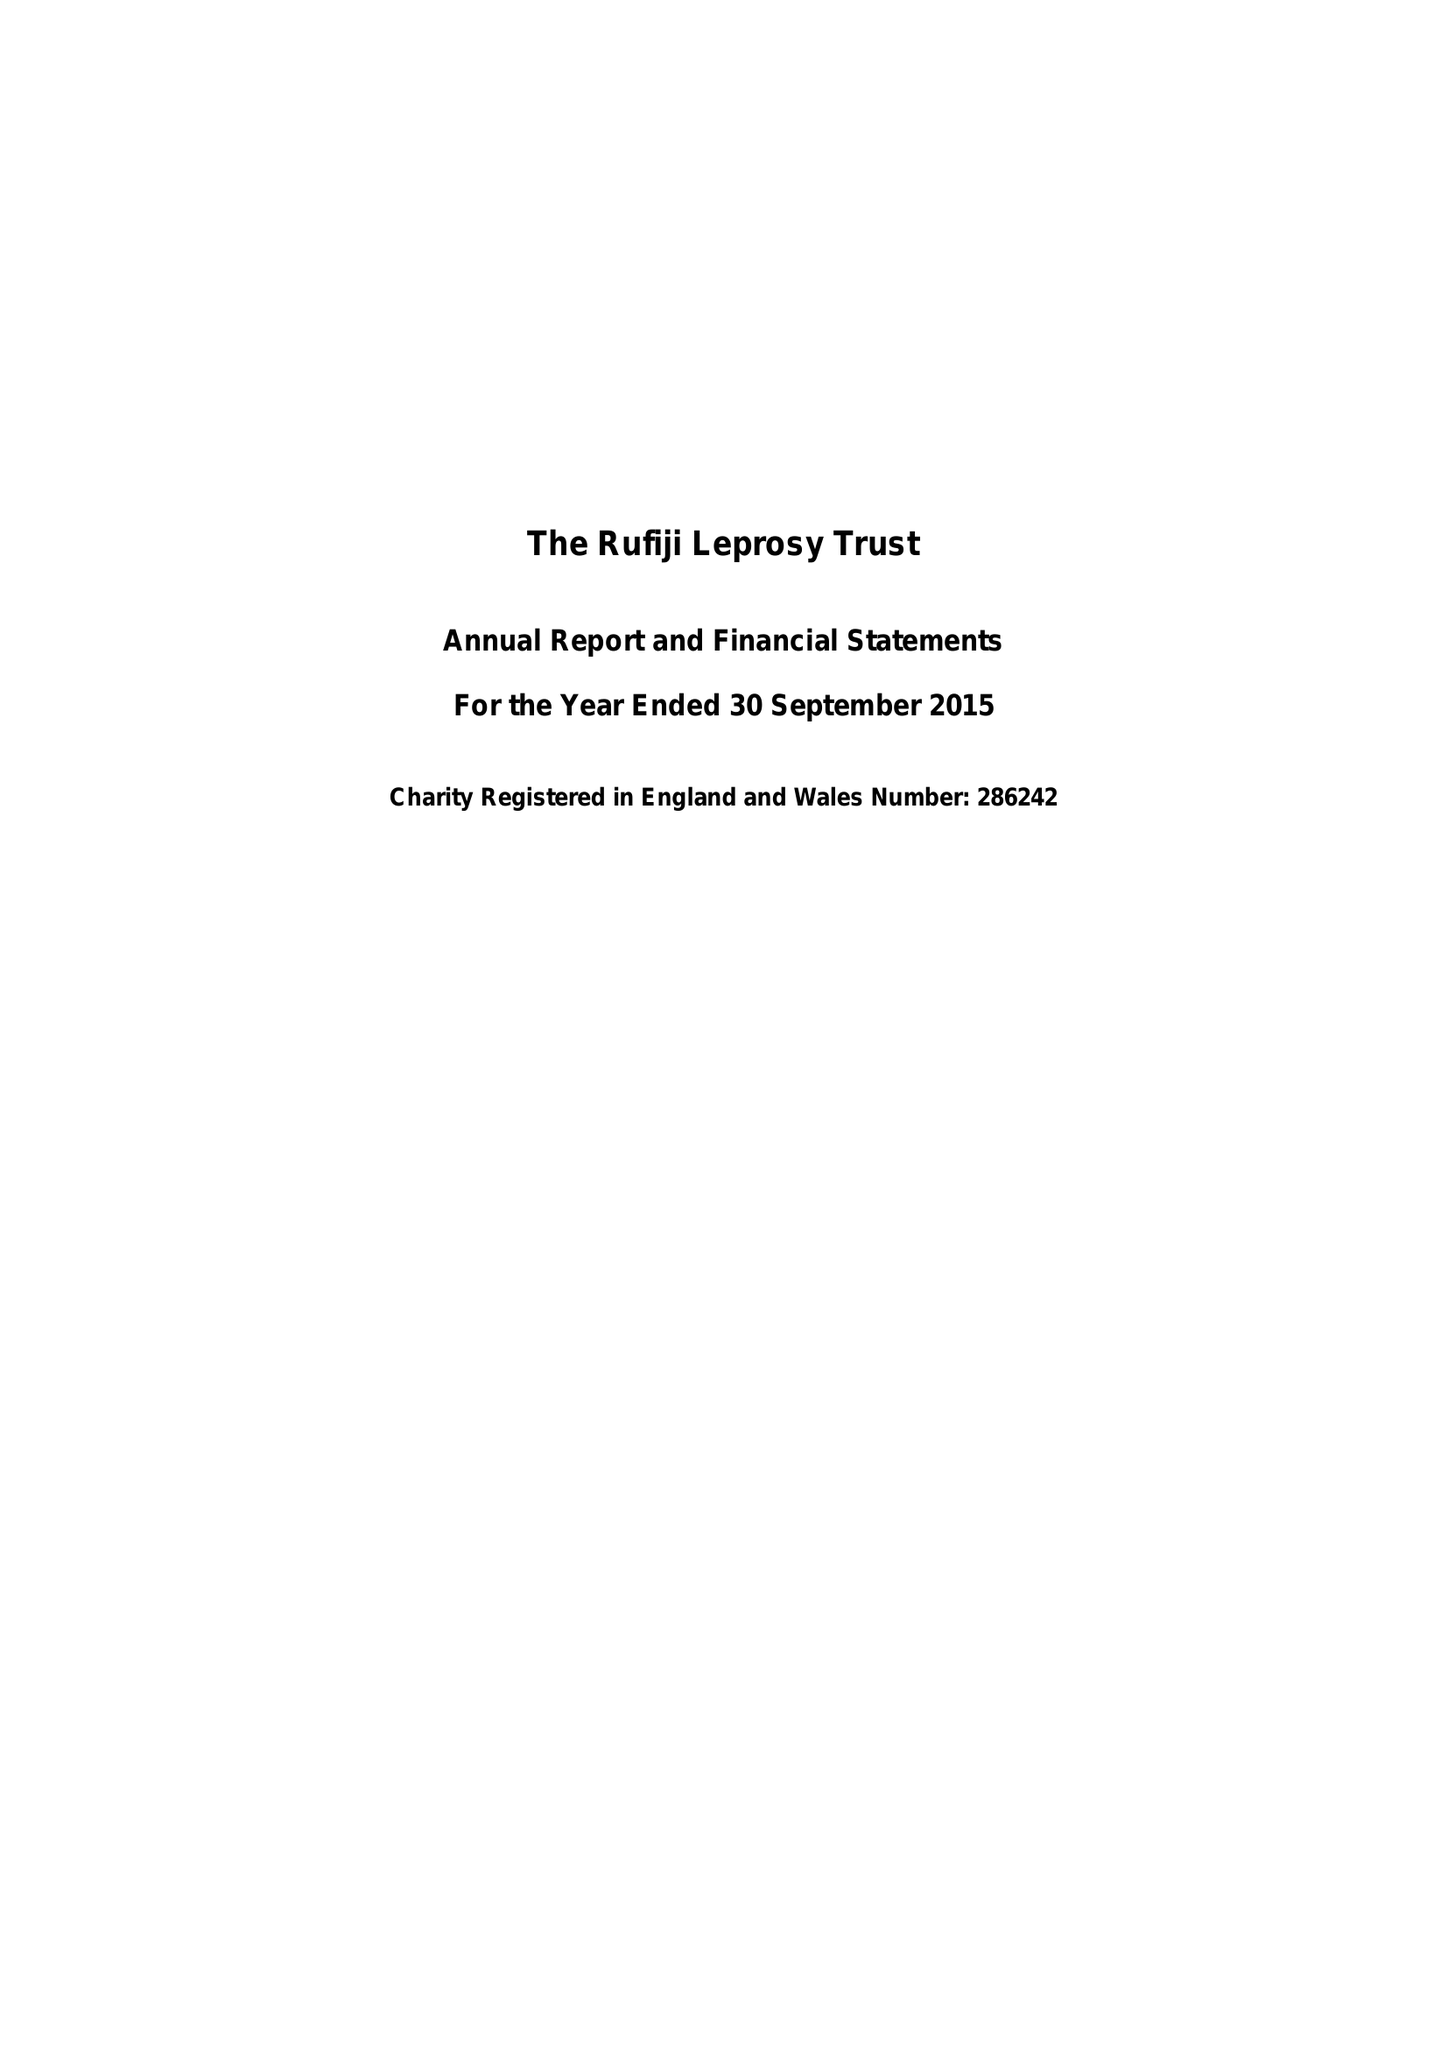What is the value for the address__street_line?
Answer the question using a single word or phrase. 55 WESTMINSTER BRIDGE ROAD 